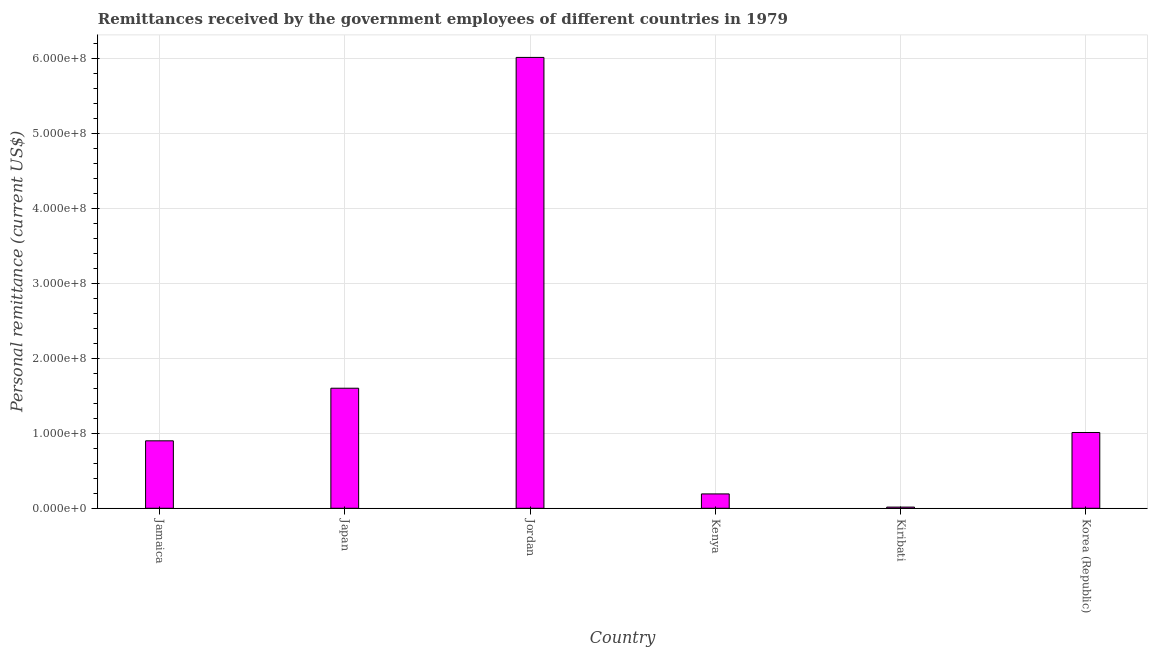Does the graph contain any zero values?
Offer a very short reply. No. Does the graph contain grids?
Your response must be concise. Yes. What is the title of the graph?
Give a very brief answer. Remittances received by the government employees of different countries in 1979. What is the label or title of the X-axis?
Provide a succinct answer. Country. What is the label or title of the Y-axis?
Your answer should be very brief. Personal remittance (current US$). What is the personal remittances in Kiribati?
Offer a terse response. 1.56e+06. Across all countries, what is the maximum personal remittances?
Your answer should be very brief. 6.01e+08. Across all countries, what is the minimum personal remittances?
Your answer should be very brief. 1.56e+06. In which country was the personal remittances maximum?
Give a very brief answer. Jordan. In which country was the personal remittances minimum?
Offer a very short reply. Kiribati. What is the sum of the personal remittances?
Ensure brevity in your answer.  9.73e+08. What is the difference between the personal remittances in Jamaica and Japan?
Provide a short and direct response. -7.01e+07. What is the average personal remittances per country?
Provide a short and direct response. 1.62e+08. What is the median personal remittances?
Offer a very short reply. 9.55e+07. What is the ratio of the personal remittances in Jordan to that in Kiribati?
Ensure brevity in your answer.  384.02. Is the personal remittances in Jamaica less than that in Kenya?
Keep it short and to the point. No. Is the difference between the personal remittances in Jordan and Kenya greater than the difference between any two countries?
Make the answer very short. No. What is the difference between the highest and the second highest personal remittances?
Provide a short and direct response. 4.41e+08. What is the difference between the highest and the lowest personal remittances?
Offer a very short reply. 5.99e+08. Are all the bars in the graph horizontal?
Offer a terse response. No. How many countries are there in the graph?
Provide a succinct answer. 6. What is the difference between two consecutive major ticks on the Y-axis?
Keep it short and to the point. 1.00e+08. What is the Personal remittance (current US$) in Jamaica?
Ensure brevity in your answer.  8.99e+07. What is the Personal remittance (current US$) in Japan?
Ensure brevity in your answer.  1.60e+08. What is the Personal remittance (current US$) of Jordan?
Provide a short and direct response. 6.01e+08. What is the Personal remittance (current US$) in Kenya?
Your answer should be very brief. 1.91e+07. What is the Personal remittance (current US$) of Kiribati?
Give a very brief answer. 1.56e+06. What is the Personal remittance (current US$) of Korea (Republic)?
Provide a short and direct response. 1.01e+08. What is the difference between the Personal remittance (current US$) in Jamaica and Japan?
Your response must be concise. -7.01e+07. What is the difference between the Personal remittance (current US$) in Jamaica and Jordan?
Give a very brief answer. -5.11e+08. What is the difference between the Personal remittance (current US$) in Jamaica and Kenya?
Offer a terse response. 7.08e+07. What is the difference between the Personal remittance (current US$) in Jamaica and Kiribati?
Your answer should be very brief. 8.83e+07. What is the difference between the Personal remittance (current US$) in Jamaica and Korea (Republic)?
Give a very brief answer. -1.11e+07. What is the difference between the Personal remittance (current US$) in Japan and Jordan?
Provide a succinct answer. -4.41e+08. What is the difference between the Personal remittance (current US$) in Japan and Kenya?
Provide a succinct answer. 1.41e+08. What is the difference between the Personal remittance (current US$) in Japan and Kiribati?
Offer a very short reply. 1.58e+08. What is the difference between the Personal remittance (current US$) in Japan and Korea (Republic)?
Provide a succinct answer. 5.90e+07. What is the difference between the Personal remittance (current US$) in Jordan and Kenya?
Provide a succinct answer. 5.82e+08. What is the difference between the Personal remittance (current US$) in Jordan and Kiribati?
Offer a very short reply. 5.99e+08. What is the difference between the Personal remittance (current US$) in Jordan and Korea (Republic)?
Provide a succinct answer. 5.00e+08. What is the difference between the Personal remittance (current US$) in Kenya and Kiribati?
Provide a succinct answer. 1.76e+07. What is the difference between the Personal remittance (current US$) in Kenya and Korea (Republic)?
Your response must be concise. -8.19e+07. What is the difference between the Personal remittance (current US$) in Kiribati and Korea (Republic)?
Offer a terse response. -9.94e+07. What is the ratio of the Personal remittance (current US$) in Jamaica to that in Japan?
Your answer should be very brief. 0.56. What is the ratio of the Personal remittance (current US$) in Jamaica to that in Jordan?
Keep it short and to the point. 0.15. What is the ratio of the Personal remittance (current US$) in Jamaica to that in Kenya?
Offer a very short reply. 4.7. What is the ratio of the Personal remittance (current US$) in Jamaica to that in Kiribati?
Provide a succinct answer. 57.45. What is the ratio of the Personal remittance (current US$) in Jamaica to that in Korea (Republic)?
Your answer should be very brief. 0.89. What is the ratio of the Personal remittance (current US$) in Japan to that in Jordan?
Your response must be concise. 0.27. What is the ratio of the Personal remittance (current US$) in Japan to that in Kenya?
Your response must be concise. 8.36. What is the ratio of the Personal remittance (current US$) in Japan to that in Kiribati?
Your response must be concise. 102.25. What is the ratio of the Personal remittance (current US$) in Japan to that in Korea (Republic)?
Your answer should be compact. 1.58. What is the ratio of the Personal remittance (current US$) in Jordan to that in Kenya?
Your answer should be very brief. 31.4. What is the ratio of the Personal remittance (current US$) in Jordan to that in Kiribati?
Offer a terse response. 384.02. What is the ratio of the Personal remittance (current US$) in Jordan to that in Korea (Republic)?
Give a very brief answer. 5.95. What is the ratio of the Personal remittance (current US$) in Kenya to that in Kiribati?
Your response must be concise. 12.23. What is the ratio of the Personal remittance (current US$) in Kenya to that in Korea (Republic)?
Your answer should be compact. 0.19. What is the ratio of the Personal remittance (current US$) in Kiribati to that in Korea (Republic)?
Your answer should be compact. 0.01. 